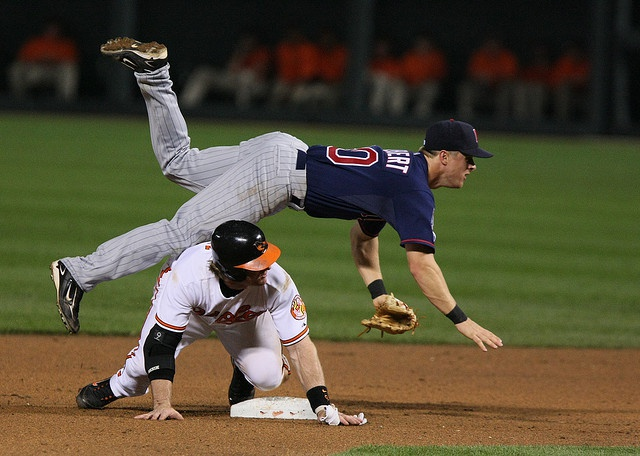Describe the objects in this image and their specific colors. I can see people in black, darkgray, and gray tones, people in black, lavender, olive, and maroon tones, people in black and gray tones, people in black, maroon, and gray tones, and people in maroon and black tones in this image. 